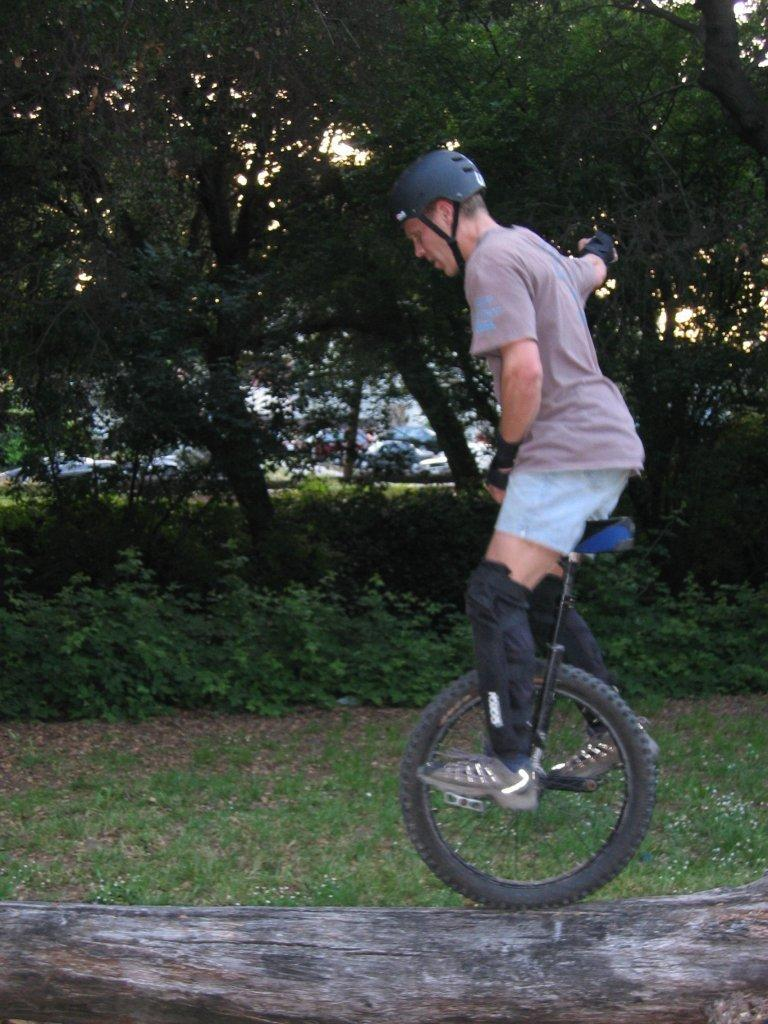What is the main subject of the image? There is a person standing in the image. What is the person standing on? The person is standing on a moon cycle. Where is the moon cycle located? The moon cycle is on the stem of a tree. What can be seen in the background of the image? There are trees in the background of the image. What type of alarm can be heard going off in the image? There is no alarm present in the image. 